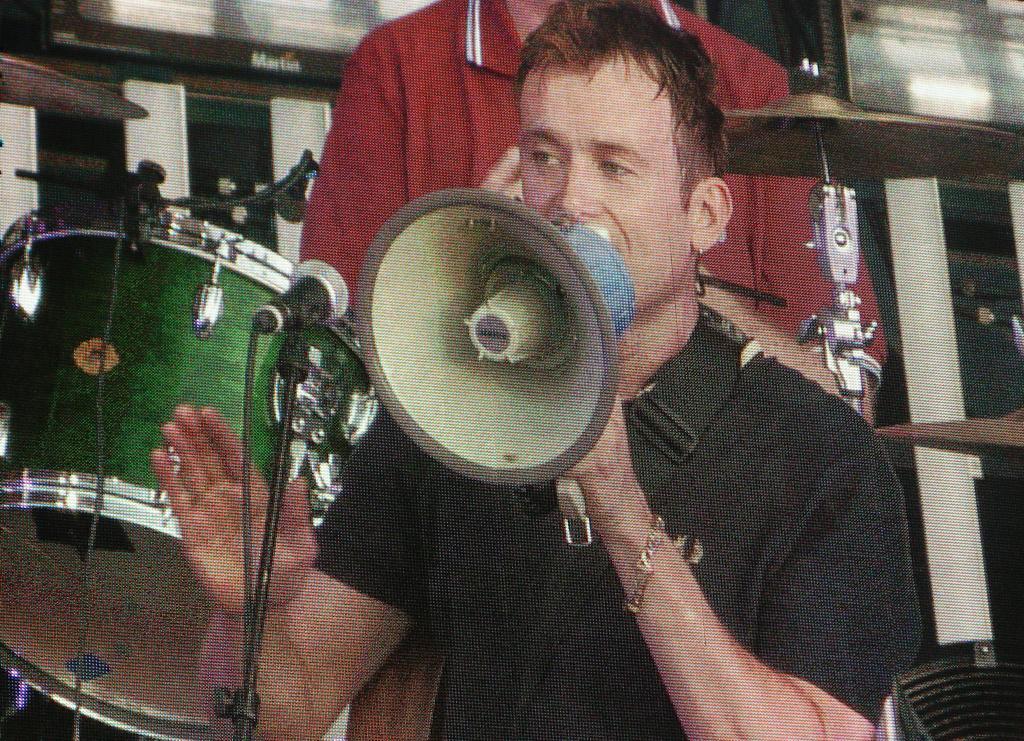How would you summarize this image in a sentence or two? In this image I can see the person holding the megaphone and the person is wearing black color shirt. In the background I can see the other person and I can see few musical instruments. 